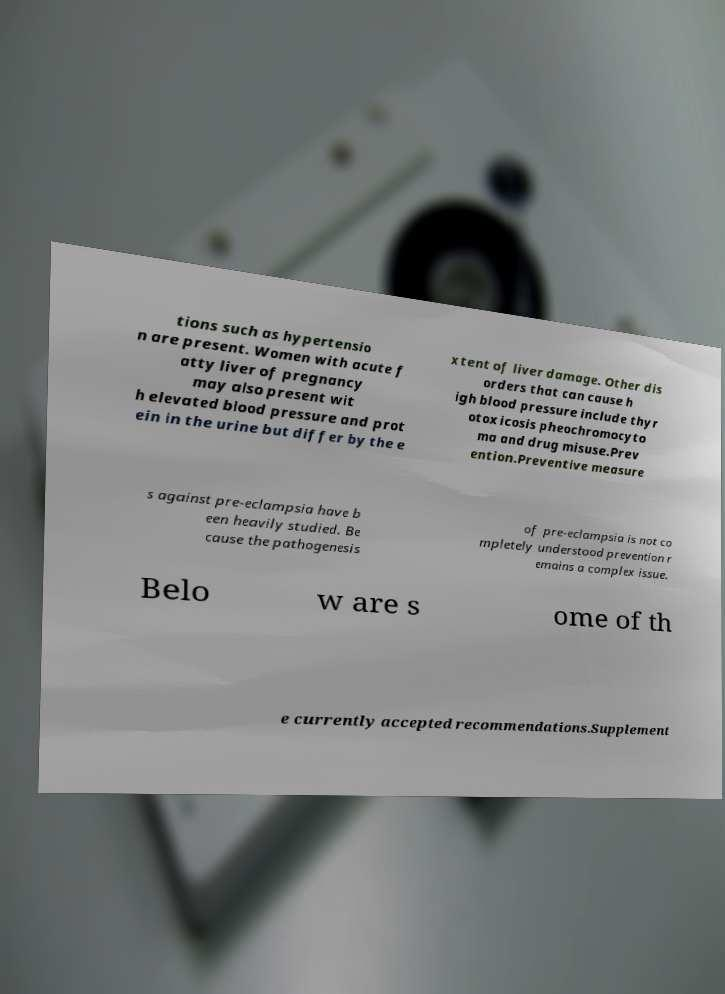I need the written content from this picture converted into text. Can you do that? tions such as hypertensio n are present. Women with acute f atty liver of pregnancy may also present wit h elevated blood pressure and prot ein in the urine but differ by the e xtent of liver damage. Other dis orders that can cause h igh blood pressure include thyr otoxicosis pheochromocyto ma and drug misuse.Prev ention.Preventive measure s against pre-eclampsia have b een heavily studied. Be cause the pathogenesis of pre-eclampsia is not co mpletely understood prevention r emains a complex issue. Belo w are s ome of th e currently accepted recommendations.Supplement 